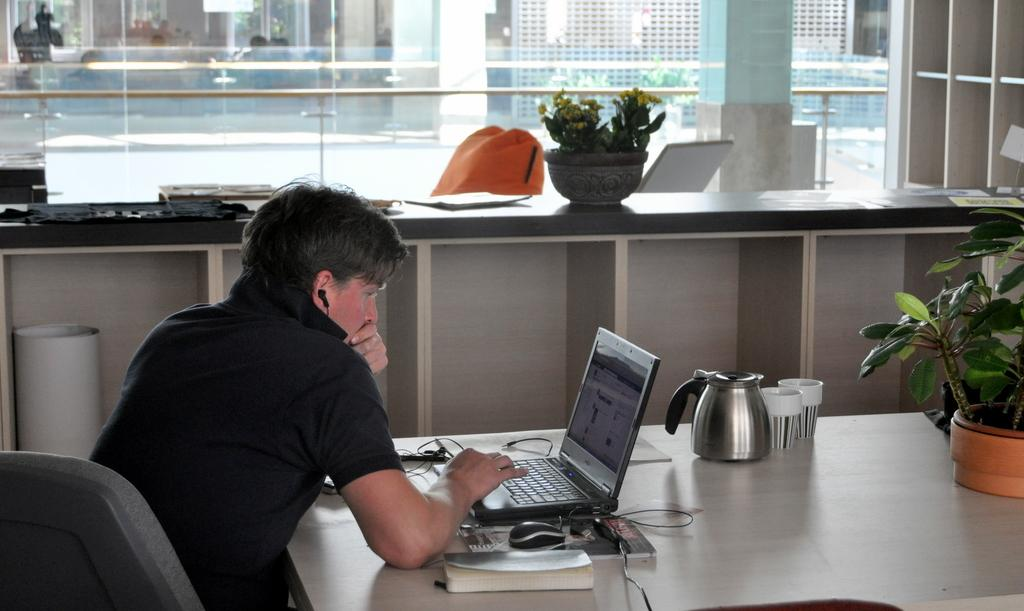What is the main subject of the image? There is a man in the image. What is the man doing in the image? The man is sitting on a chair. What objects can be seen on the table in the image? There is a laptop, a mouse, a book, a kettle, and glasses on the table. What sign of shame can be seen on the man's face in the image? There is no indication of shame or any facial expression on the man's face in the image. What type of hearing device is present on the table in the image? There are no hearing devices present on the table in the image. 